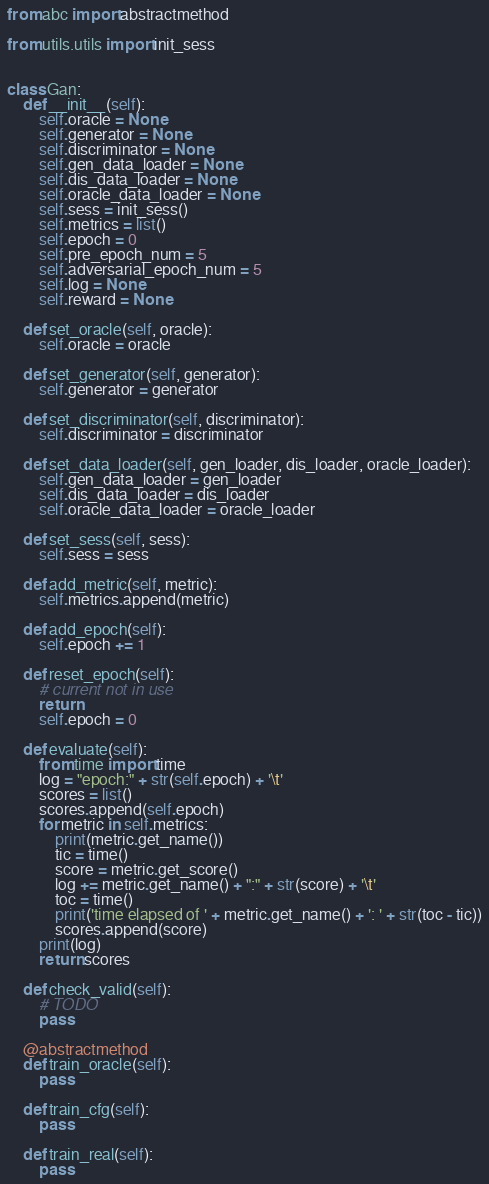<code> <loc_0><loc_0><loc_500><loc_500><_Python_>from abc import abstractmethod

from utils.utils import init_sess


class Gan:
    def __init__(self):
        self.oracle = None
        self.generator = None
        self.discriminator = None
        self.gen_data_loader = None
        self.dis_data_loader = None
        self.oracle_data_loader = None
        self.sess = init_sess()
        self.metrics = list()
        self.epoch = 0
        self.pre_epoch_num = 5
        self.adversarial_epoch_num = 5
        self.log = None
        self.reward = None

    def set_oracle(self, oracle):
        self.oracle = oracle

    def set_generator(self, generator):
        self.generator = generator

    def set_discriminator(self, discriminator):
        self.discriminator = discriminator

    def set_data_loader(self, gen_loader, dis_loader, oracle_loader):
        self.gen_data_loader = gen_loader
        self.dis_data_loader = dis_loader
        self.oracle_data_loader = oracle_loader

    def set_sess(self, sess):
        self.sess = sess

    def add_metric(self, metric):
        self.metrics.append(metric)

    def add_epoch(self):
        self.epoch += 1

    def reset_epoch(self):
        # current not in use
        return
        self.epoch = 0

    def evaluate(self):
        from time import time
        log = "epoch:" + str(self.epoch) + '\t'
        scores = list()
        scores.append(self.epoch)
        for metric in self.metrics:
            print(metric.get_name())
            tic = time()
            score = metric.get_score()
            log += metric.get_name() + ":" + str(score) + '\t'
            toc = time()
            print('time elapsed of ' + metric.get_name() + ': ' + str(toc - tic))
            scores.append(score)
        print(log)
        return scores

    def check_valid(self):
        # TODO
        pass

    @abstractmethod
    def train_oracle(self):
        pass

    def train_cfg(self):
        pass

    def train_real(self):
        pass
</code> 